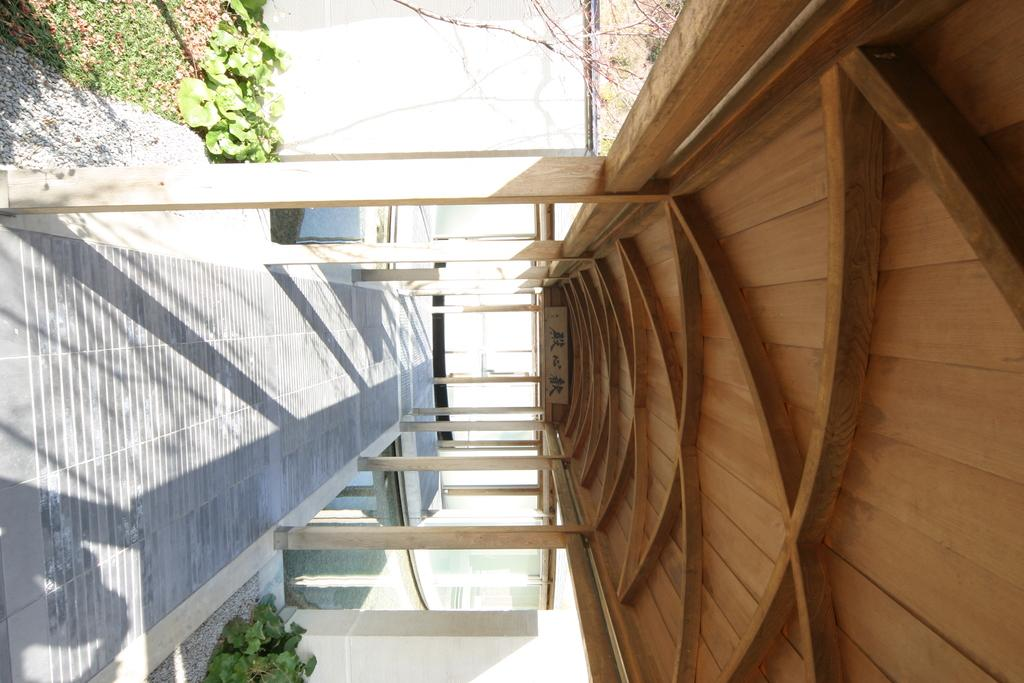What type of path is visible in the image? There is a walkway in the image. What kind of structure is present above the walkway? There is a wooden roof with pillars in the image. Are there any natural elements in the image? Yes, there are plants in the image. What scent can be detected from the plants in the image? The image does not provide information about the scent of the plants, so it cannot be determined from the image. Can you see a goose in the image? There is no goose present in the image. 